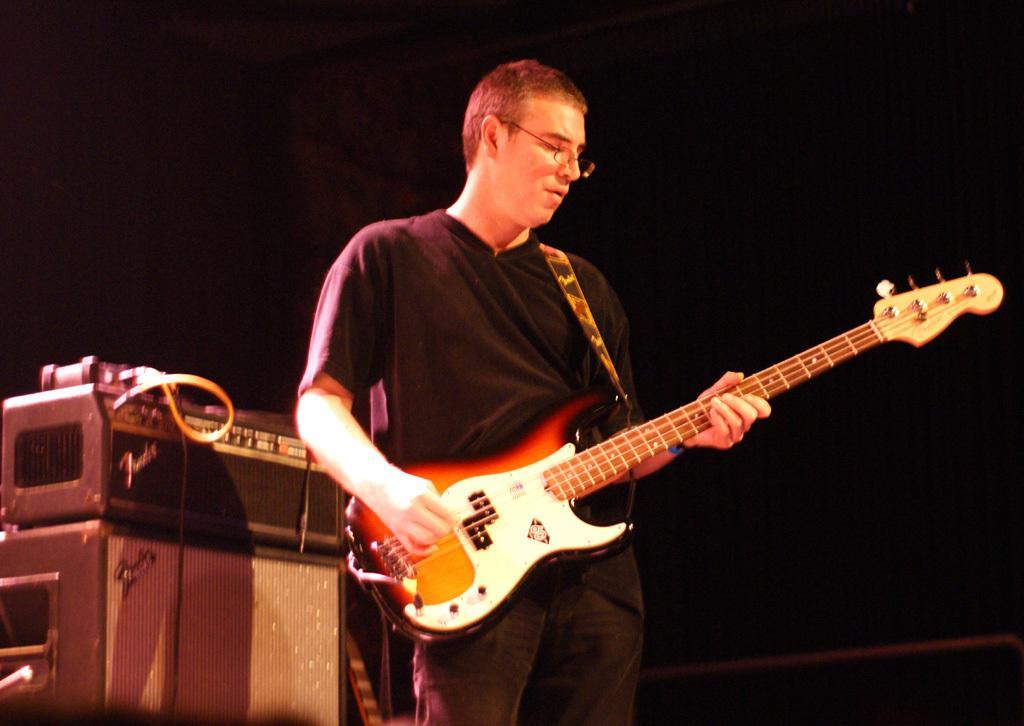Can you describe this image briefly? In this picture we can see man holding guitar in his hand and playing it and standing and beside to him we have speakers, some machine and in the background it is dark. 